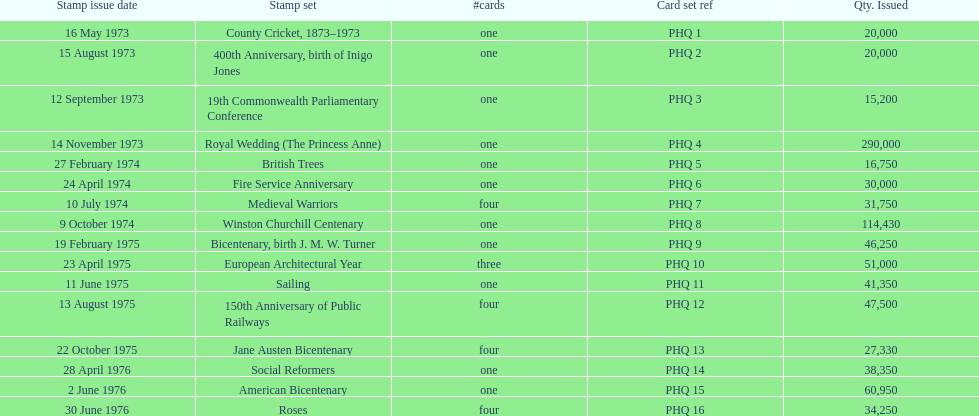Which stamp set had the greatest quantity issued? Royal Wedding (The Princess Anne). 